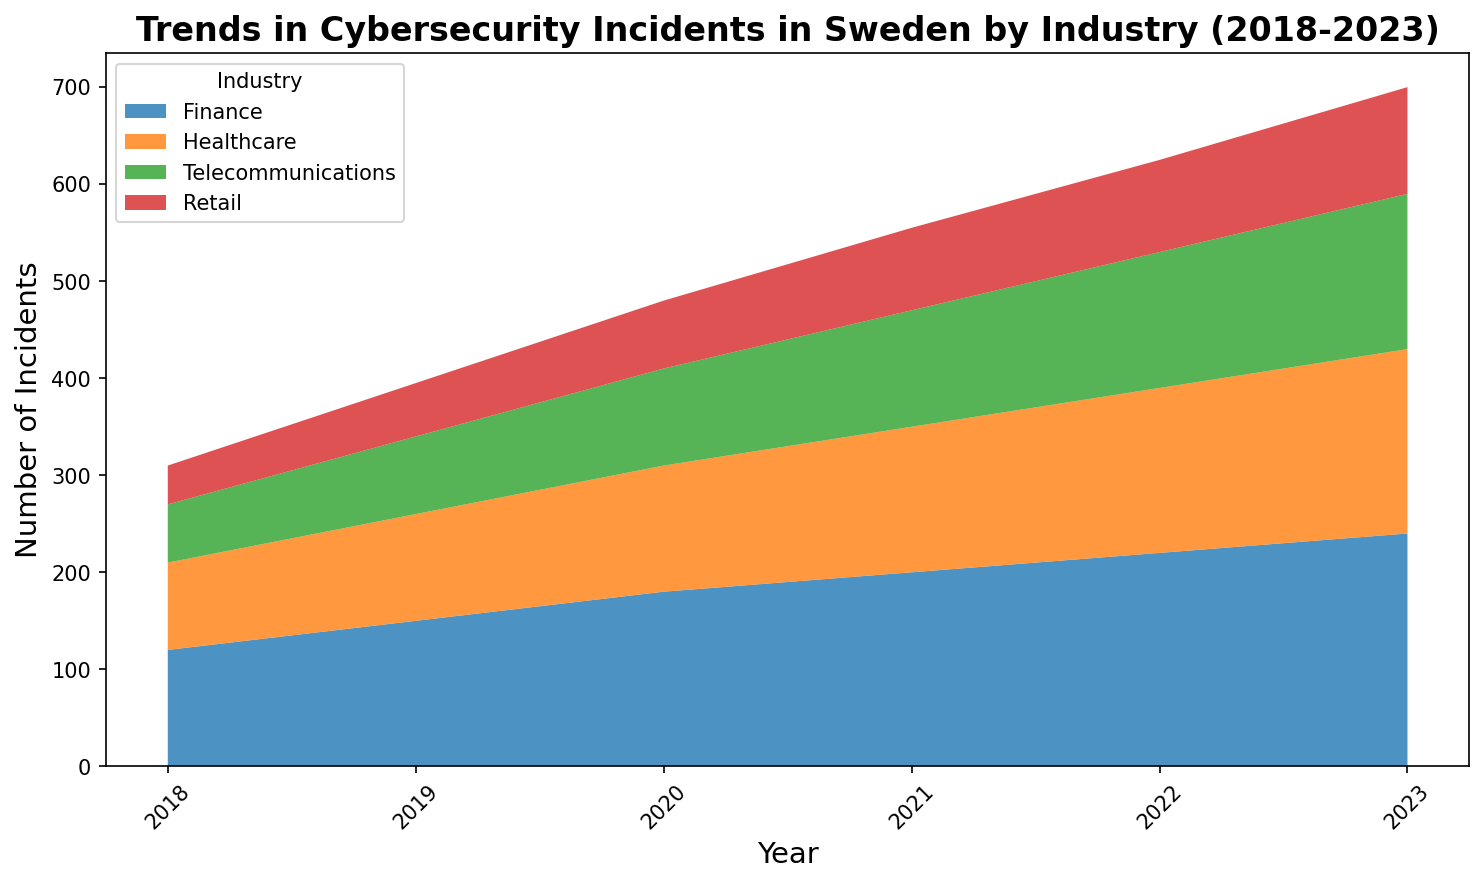What trend do we see in the total number of cybersecurity incidents across all industries from 2018 to 2023? To determine the trend, observe the cumulative height of the stacked areas throughout the years. Each year shows an increase in the height of the stacked areas, indicating a rising trend in the total number of cybersecurity incidents.
Answer: Increasing trend Which industry experienced the highest increase in the number of incidents over the five years? Look at the height difference in the individual stacked areas from 2018 to 2023 for each industry. The finance industry's area increased the most considerably, indicating the highest rise in incidents.
Answer: Finance By how much did the number of incidents in the Healthcare industry increase from 2018 to 2023? Refer to the stacked area for Healthcare in 2018 and 2023. In 2018, it was 90; in 2023, it was 190. Calculating the difference gives 190 - 90 = 100.
Answer: 100 Which year saw the most significant jump in the number of cybersecurity incidents in Retail? Evaluate the change in the height of the Retail section year by year. The significant jump happened from 2020 to 2021, where the value increased from 70 to 85.
Answer: 2021 Comparing the number of incidents in Telecommunications and Retail in 2023, which industry had more? Find the height of the individual stacked areas for both industries in 2023. Telecommunications had 160 incidents, and Retail had 110, so Telecommunications had more.
Answer: Telecommunications Which industry consistently had the lowest number of incidents over the five years? Compare the height of the stacked areas of all industries each year. Retail consistently has the smallest area across all years.
Answer: Retail What is the average number of incidents per year for the Finance industry over the five years? Sum the annual incidents in the Finance industry from 2018 to 2023: 120 + 150 + 180 + 200 + 220 + 240 = 1110. Divide by the number of years (6): 1110/6 = 185.
Answer: 185 In which year did the combined number of incidents in Healthcare and Telecommunications surpass 200 for the first time? Calculate the sum of incidents in Healthcare and Telecommunications for each year and observe when the total surpasses 200. In 2019, Healthcare had 110 and Telecommunications had 80, totaling 190. In 2020, Healthcare had 130 and Telecommunications had 100, totaling 230. Thus, 2020 is the year when the combined number surpassed 200.
Answer: 2020 How does the trend in the number of incidents in Healthcare compare to that in Telecommunications? Observe the growth in the stacked areas of both Healthcare and Telecommunications from 2018 to 2023. While both show an increasing trend, the rise in Healthcare incidents is steeper compared to that in Telecommunications. This indicates a faster growth rate in Healthcare.
Answer: Healthcare's trend is steeper 